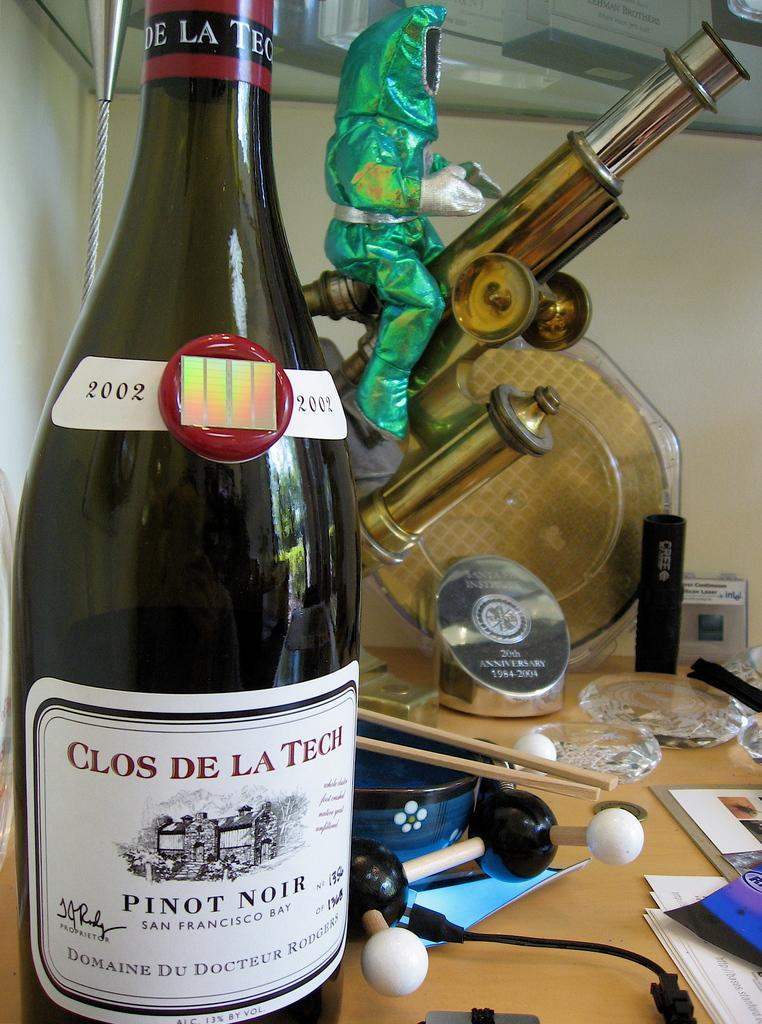<image>
Provide a brief description of the given image. Bottle of alcohol that has the year 2002 on the top. 